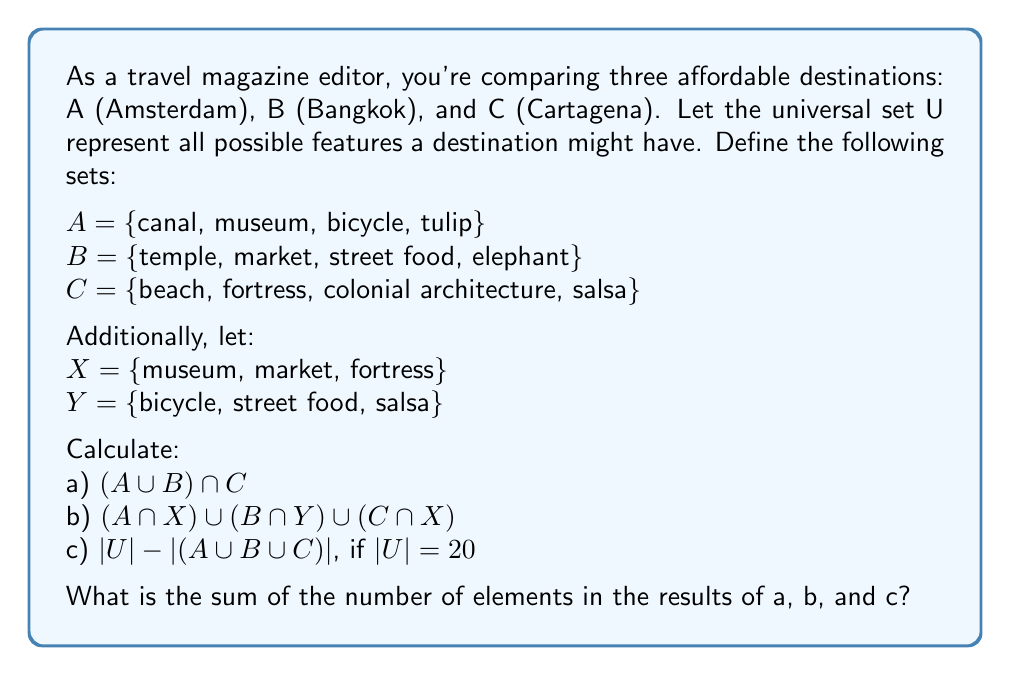Could you help me with this problem? Let's solve this problem step by step:

a) $(A \cup B) \cap C$
   First, we find $A \cup B$:
   $A \cup B = \{canal, museum, bicycle, tulip, temple, market, street food, elephant\}$
   Then, we intersect this with C:
   $(A \cup B) \cap C = \{\}$ (empty set)
   There are 0 elements in this set.

b) $(A \cap X) \cup (B \cap Y) \cup (C \cap X)$
   Let's break this down:
   $A \cap X = \{museum\}$
   $B \cap Y = \{street food\}$
   $C \cap X = \{fortress\}$
   Now, we unite these sets:
   $(A \cap X) \cup (B \cap Y) \cup (C \cap X) = \{museum, street food, fortress\}$
   There are 3 elements in this set.

c) $|U| - |(A \cup B \cup C)|$, if $|U| = 20$
   First, we need to find $A \cup B \cup C$:
   $A \cup B \cup C = \{canal, museum, bicycle, tulip, temple, market, street food, elephant, beach, fortress, colonial architecture, salsa\}$
   $|A \cup B \cup C| = 12$
   Now we can calculate:
   $|U| - |(A \cup B \cup C)| = 20 - 12 = 8$

The sum of the number of elements in the results of a, b, and c is:
$0 + 3 + 8 = 11$
Answer: 11 